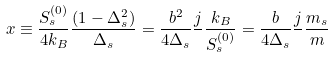Convert formula to latex. <formula><loc_0><loc_0><loc_500><loc_500>x \equiv \frac { S _ { s } ^ { ( 0 ) } } { 4 k _ { B } } \frac { ( 1 - \Delta _ { s } ^ { 2 } ) } { \Delta _ { s } } = \frac { b ^ { 2 } } { 4 \Delta _ { s } } \frac { j } { } \frac { k _ { B } } { S _ { s } ^ { ( 0 ) } } = \frac { b } { 4 \Delta _ { s } } \frac { j } { } \frac { m _ { s } } { m }</formula> 